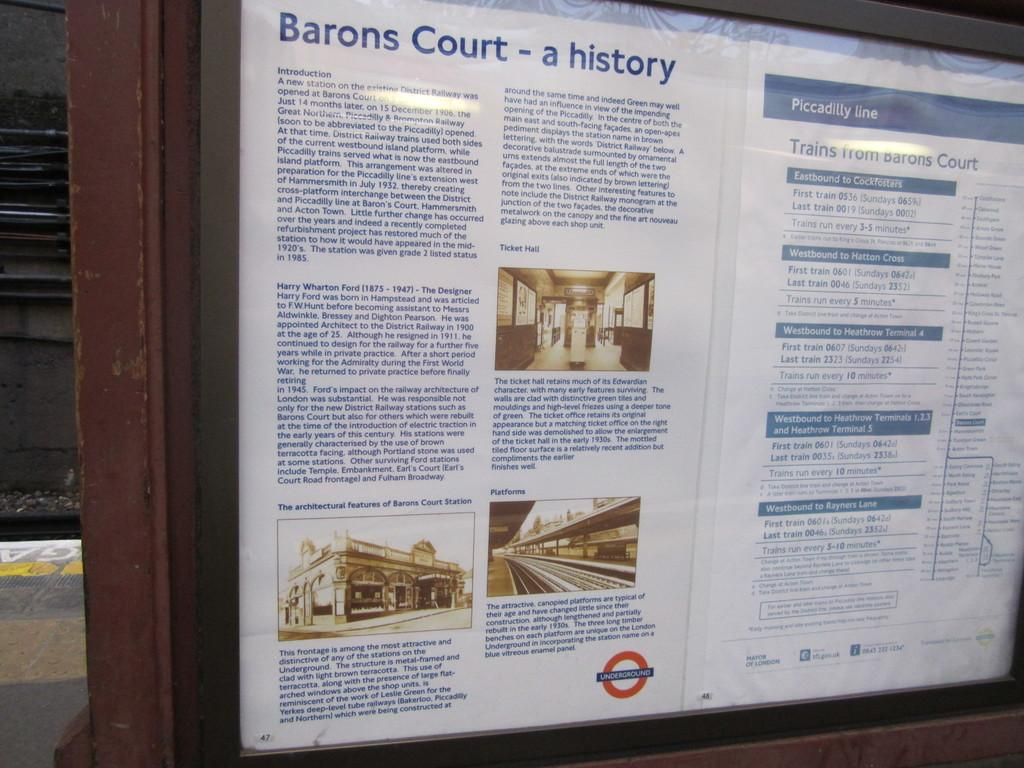<image>
Describe the image concisely. a display board of the Barons court history is mounted for reading 